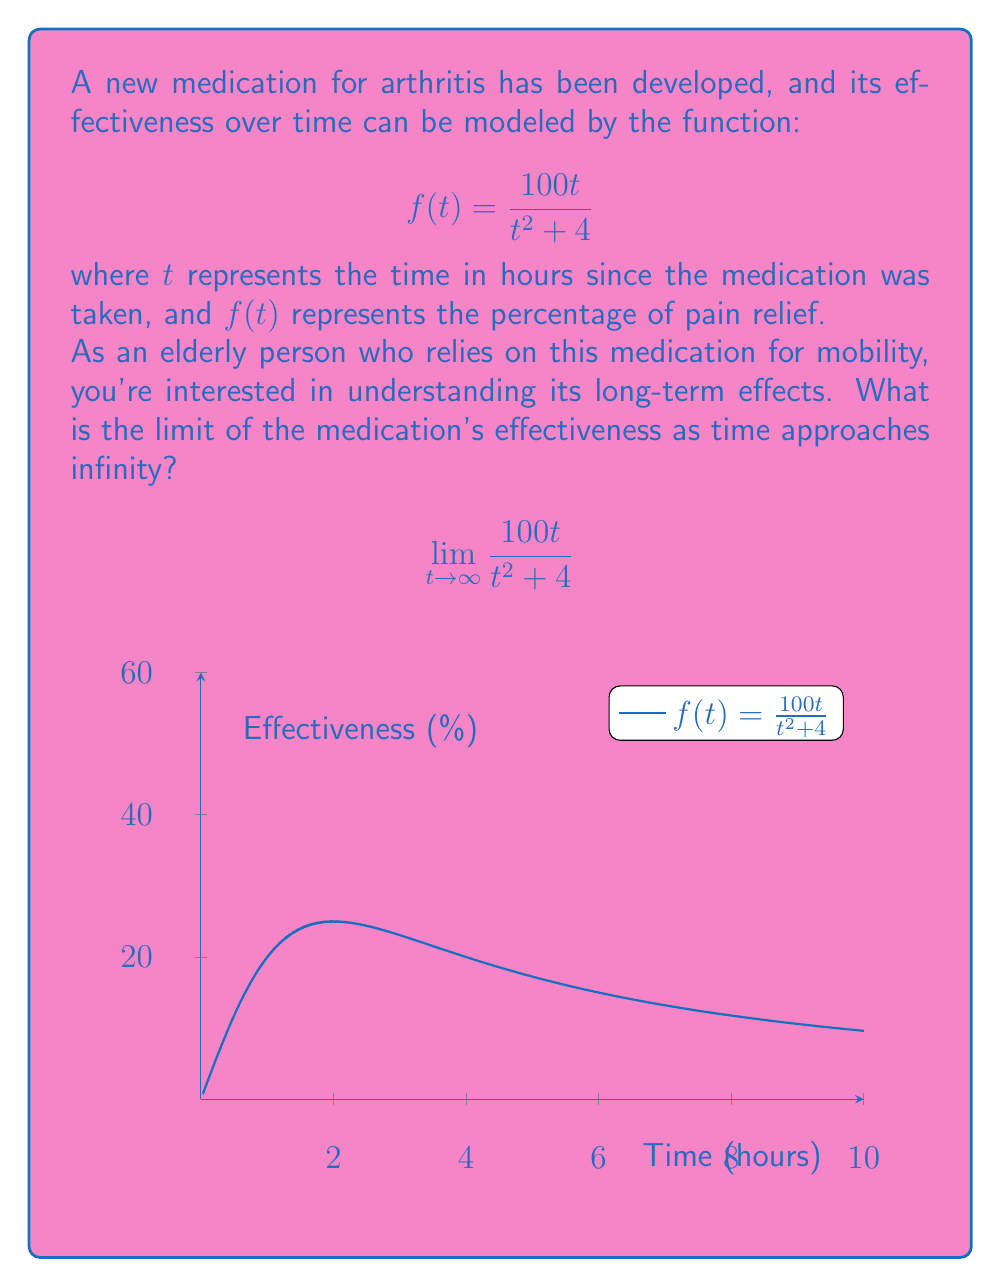Show me your answer to this math problem. Let's approach this step-by-step:

1) To find the limit as $t$ approaches infinity, we need to analyze the behavior of the function for very large values of $t$.

2) We can use the concept of dividing both numerator and denominator by the highest power of $t$ in the denominator:

   $$\lim_{t \to \infty} \frac{100t}{t^2 + 4} = \lim_{t \to \infty} \frac{100t/t^2}{(t^2 + 4)/t^2}$$

3) Simplify:
   
   $$\lim_{t \to \infty} \frac{100/t}{1 + 4/t^2}$$

4) As $t$ approaches infinity:
   - $1/t$ approaches 0
   - $4/t^2$ approaches 0

5) Therefore:

   $$\lim_{t \to \infty} \frac{100/t}{1 + 4/t^2} = \frac{0}{1 + 0} = 0$$

This means that as time goes on, the effectiveness of the medication approaches 0%.
Answer: $0$ 